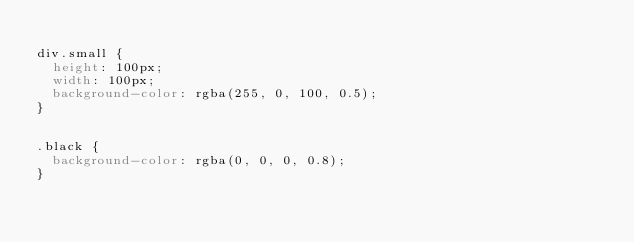<code> <loc_0><loc_0><loc_500><loc_500><_CSS_>
div.small {
  height: 100px;
  width: 100px;
  background-color: rgba(255, 0, 100, 0.5);
}


.black {
  background-color: rgba(0, 0, 0, 0.8);
}
</code> 